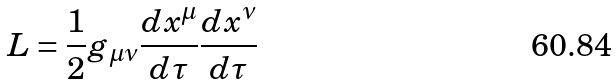<formula> <loc_0><loc_0><loc_500><loc_500>L = \frac { 1 } { 2 } g _ { \mu \nu } \frac { d x ^ { \mu } } { d \tau } \frac { d x ^ { \nu } } { d \tau }</formula> 